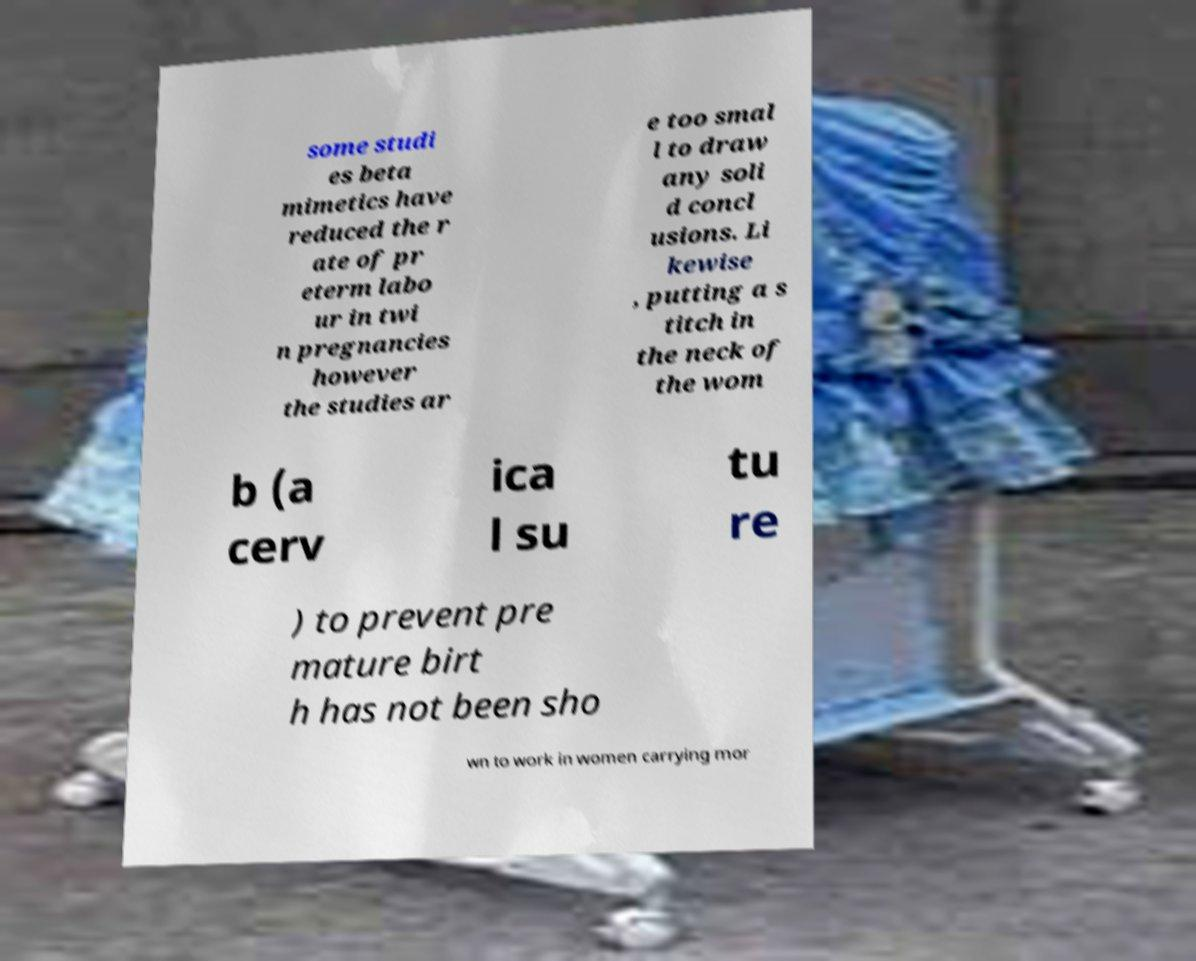What messages or text are displayed in this image? I need them in a readable, typed format. some studi es beta mimetics have reduced the r ate of pr eterm labo ur in twi n pregnancies however the studies ar e too smal l to draw any soli d concl usions. Li kewise , putting a s titch in the neck of the wom b (a cerv ica l su tu re ) to prevent pre mature birt h has not been sho wn to work in women carrying mor 